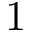<formula> <loc_0><loc_0><loc_500><loc_500>1</formula> 